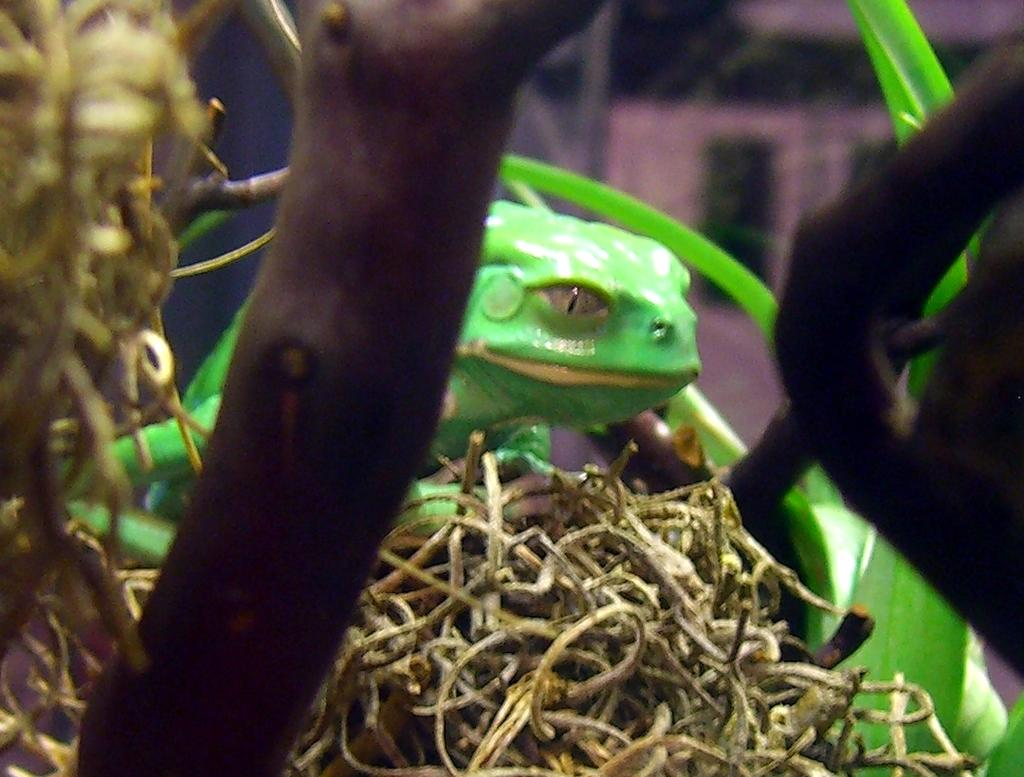What type of animal is in the image? There is a green frog in the image. What is the green frog sitting on in the image? The green frog is on dried grass. What other natural element can be seen in the image? There is a branch visible in the image. What type of jam is the frog eating in the image? There is no jam present in the image; it features a green frog on dried grass. How many volleyballs are visible in the image? There are no volleyballs present in the image. 